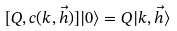<formula> <loc_0><loc_0><loc_500><loc_500>[ Q , c ( k , \vec { h } ) ] | 0 \rangle = Q | k , \vec { h } \rangle</formula> 